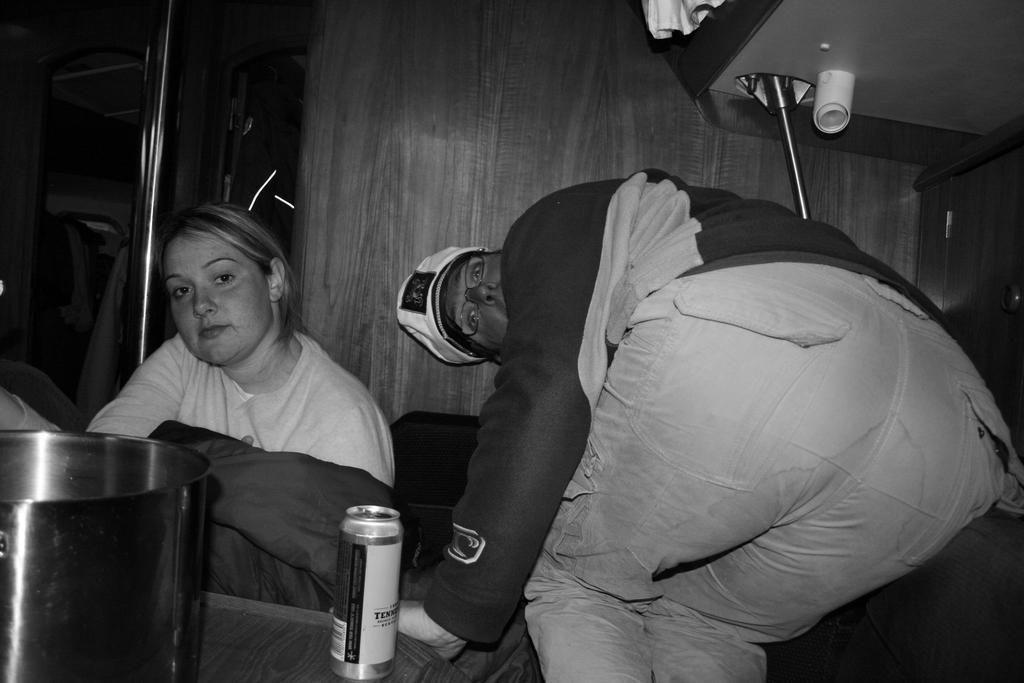How would you summarize this image in a sentence or two? This is a black and white image. In this image there is a lady. Also another person wearing specs and cap. IN the front there is a table. On that there is a steel vessel and a bottle. In the back there are rods and doors. 